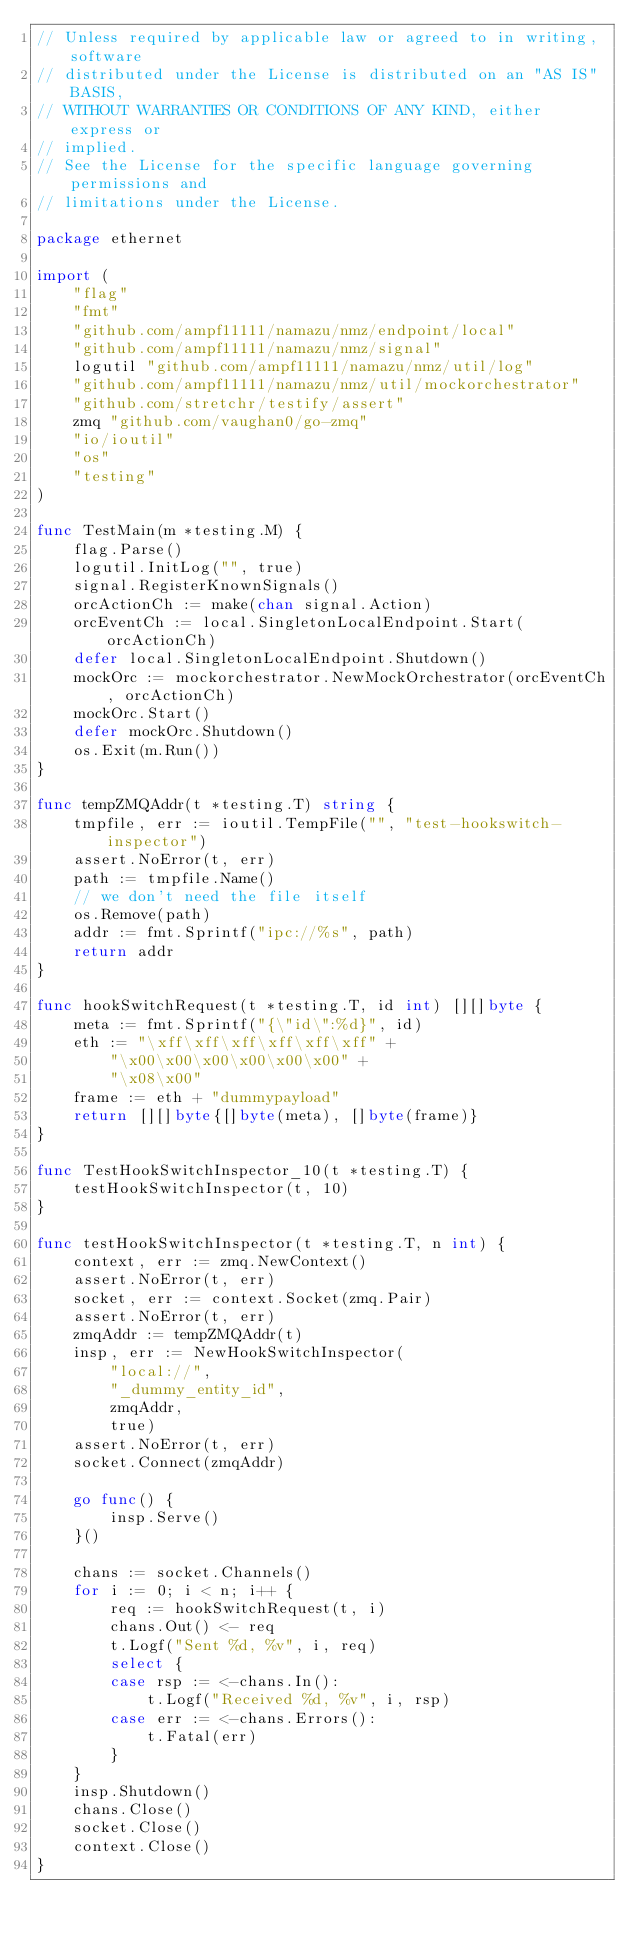Convert code to text. <code><loc_0><loc_0><loc_500><loc_500><_Go_>// Unless required by applicable law or agreed to in writing, software
// distributed under the License is distributed on an "AS IS" BASIS,
// WITHOUT WARRANTIES OR CONDITIONS OF ANY KIND, either express or
// implied.
// See the License for the specific language governing permissions and
// limitations under the License.

package ethernet

import (
	"flag"
	"fmt"
	"github.com/ampf11111/namazu/nmz/endpoint/local"
	"github.com/ampf11111/namazu/nmz/signal"
	logutil "github.com/ampf11111/namazu/nmz/util/log"
	"github.com/ampf11111/namazu/nmz/util/mockorchestrator"
	"github.com/stretchr/testify/assert"
	zmq "github.com/vaughan0/go-zmq"
	"io/ioutil"
	"os"
	"testing"
)

func TestMain(m *testing.M) {
	flag.Parse()
	logutil.InitLog("", true)
	signal.RegisterKnownSignals()
	orcActionCh := make(chan signal.Action)
	orcEventCh := local.SingletonLocalEndpoint.Start(orcActionCh)
	defer local.SingletonLocalEndpoint.Shutdown()
	mockOrc := mockorchestrator.NewMockOrchestrator(orcEventCh, orcActionCh)
	mockOrc.Start()
	defer mockOrc.Shutdown()
	os.Exit(m.Run())
}

func tempZMQAddr(t *testing.T) string {
	tmpfile, err := ioutil.TempFile("", "test-hookswitch-inspector")
	assert.NoError(t, err)
	path := tmpfile.Name()
	// we don't need the file itself
	os.Remove(path)
	addr := fmt.Sprintf("ipc://%s", path)
	return addr
}

func hookSwitchRequest(t *testing.T, id int) [][]byte {
	meta := fmt.Sprintf("{\"id\":%d}", id)
	eth := "\xff\xff\xff\xff\xff\xff" +
		"\x00\x00\x00\x00\x00\x00" +
		"\x08\x00"
	frame := eth + "dummypayload"
	return [][]byte{[]byte(meta), []byte(frame)}
}

func TestHookSwitchInspector_10(t *testing.T) {
	testHookSwitchInspector(t, 10)
}

func testHookSwitchInspector(t *testing.T, n int) {
	context, err := zmq.NewContext()
	assert.NoError(t, err)
	socket, err := context.Socket(zmq.Pair)
	assert.NoError(t, err)
	zmqAddr := tempZMQAddr(t)
	insp, err := NewHookSwitchInspector(
		"local://",
		"_dummy_entity_id",
		zmqAddr,
		true)
	assert.NoError(t, err)
	socket.Connect(zmqAddr)

	go func() {
		insp.Serve()
	}()

	chans := socket.Channels()
	for i := 0; i < n; i++ {
		req := hookSwitchRequest(t, i)
		chans.Out() <- req
		t.Logf("Sent %d, %v", i, req)
		select {
		case rsp := <-chans.In():
			t.Logf("Received %d, %v", i, rsp)
		case err := <-chans.Errors():
			t.Fatal(err)
		}
	}
	insp.Shutdown()
	chans.Close()
	socket.Close()
	context.Close()
}
</code> 